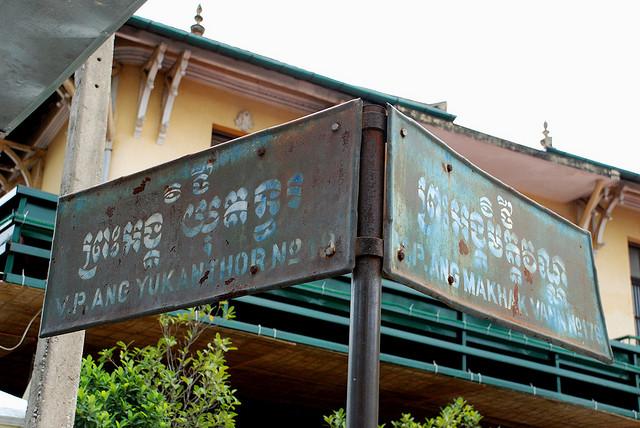Is this sign in English?
Keep it brief. No. Is this sign old?
Write a very short answer. Yes. What does the sign say?
Quick response, please. Vp ang yukamthorne. 